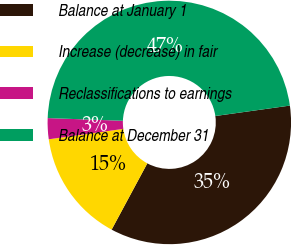Convert chart to OTSL. <chart><loc_0><loc_0><loc_500><loc_500><pie_chart><fcel>Balance at January 1<fcel>Increase (decrease) in fair<fcel>Reclassifications to earnings<fcel>Balance at December 31<nl><fcel>35.07%<fcel>14.93%<fcel>2.78%<fcel>47.22%<nl></chart> 